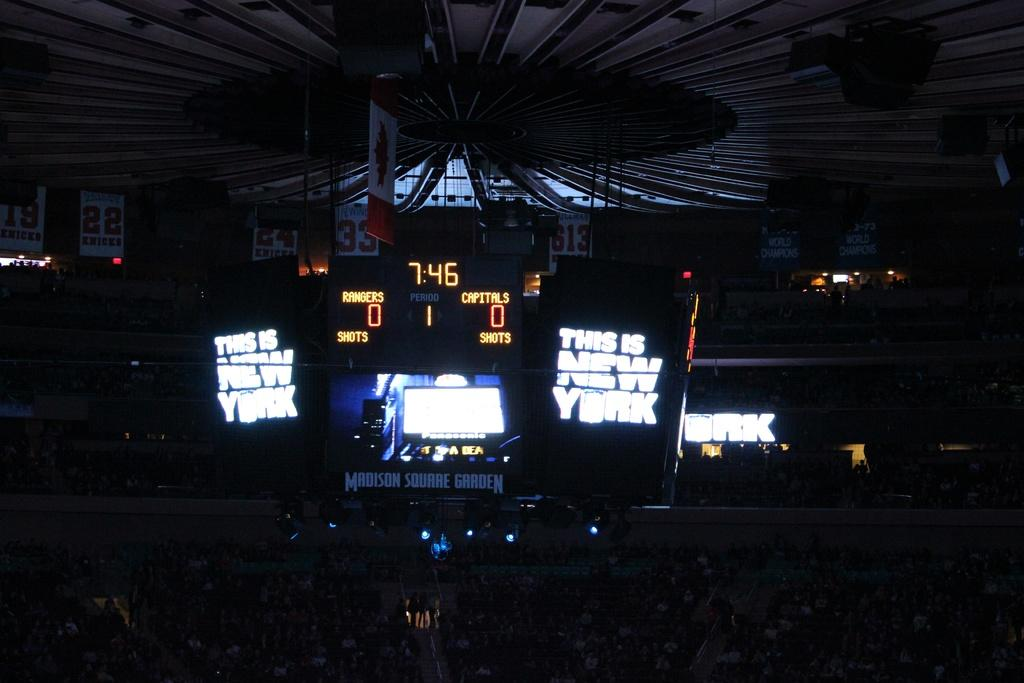<image>
Summarize the visual content of the image. a time clock that reads 7:46 with neither team having scored any points 